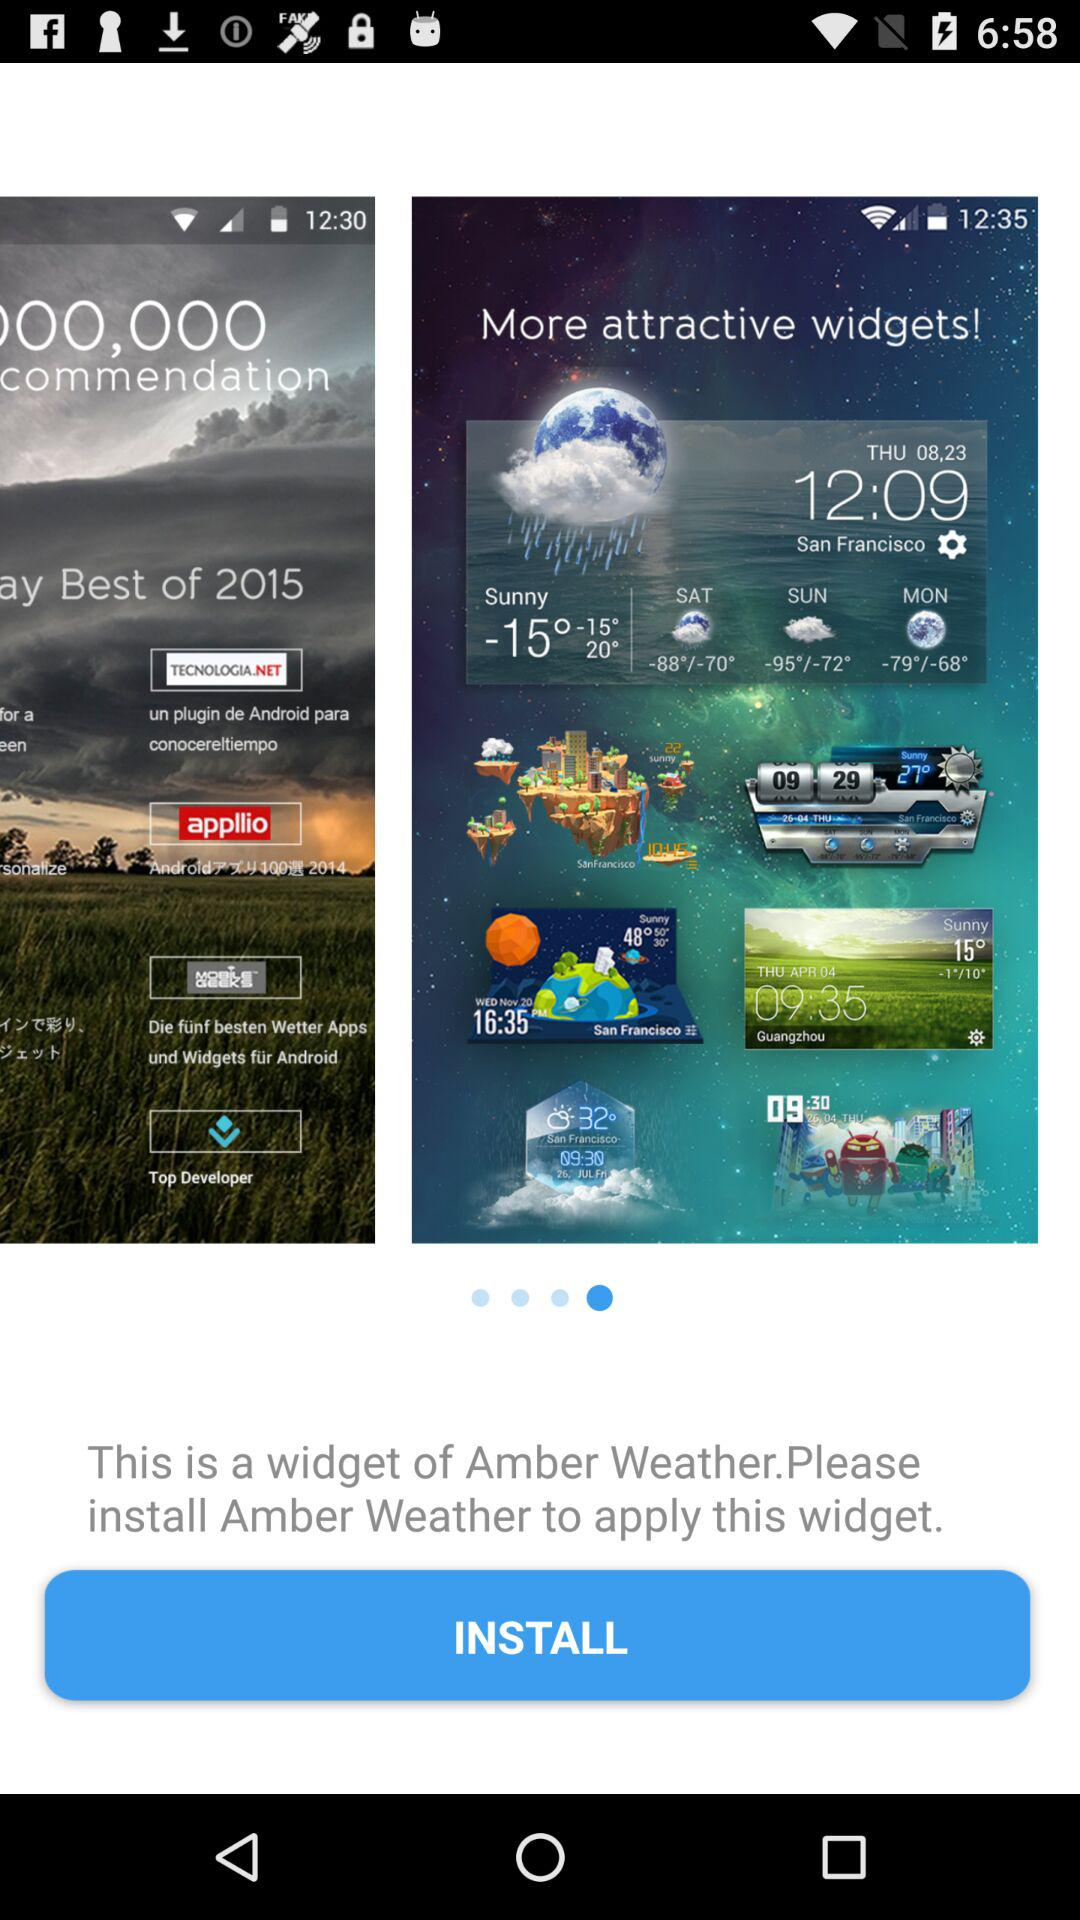What was the temperature on Monday? The temperature on Monday ranged from -79° to -68°. 